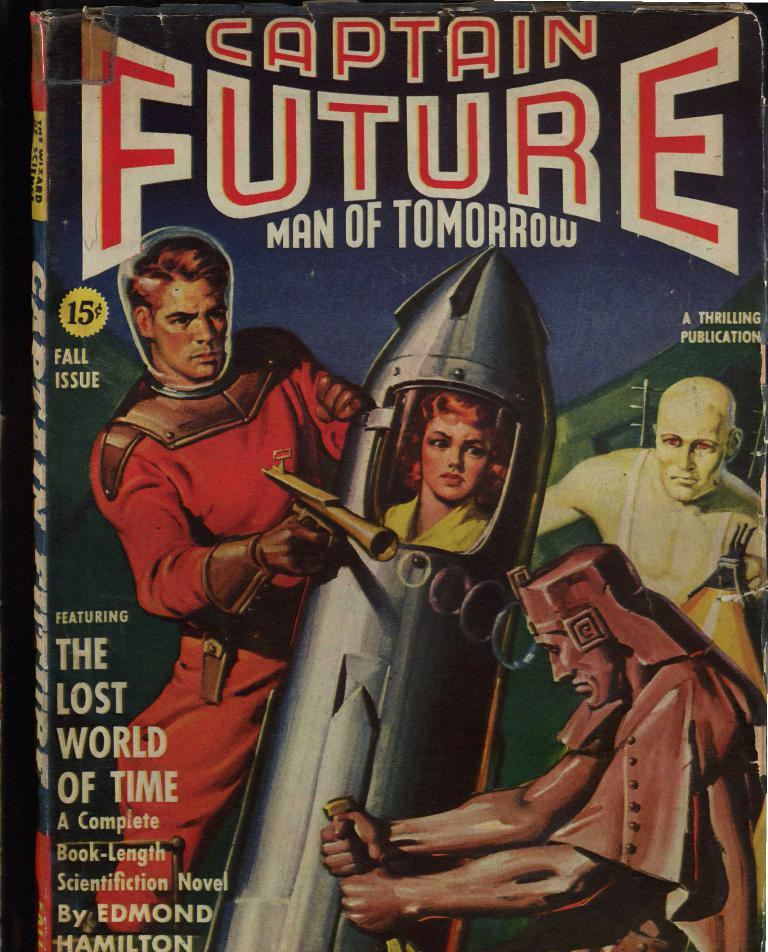What is present in the image related to advertising or information? There is a poster in the image. What can be read on the poster? The writing on the poster says "Captain Future: Man of Tomorrow." How many dimes can be seen on the poster in the image? There are no dimes present on the poster in the image. What type of expression is displayed on the poster in the image? The poster in the image does not depict a person or an expression; it only contains text. 